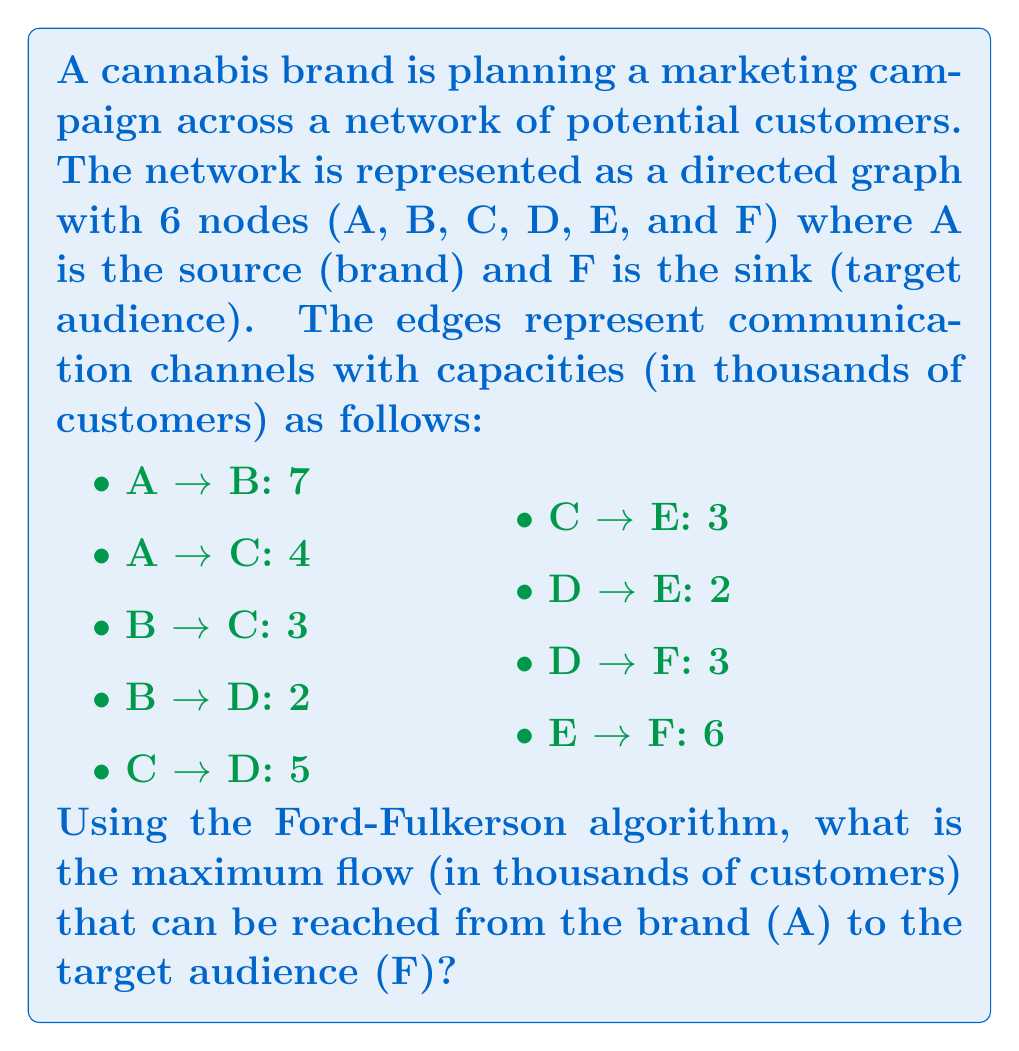Help me with this question. To solve this problem, we'll use the Ford-Fulkerson algorithm to find the maximum flow in the network. Here's a step-by-step explanation:

1. Initialize the flow to 0 for all edges.

2. Find an augmenting path from source A to sink F. We'll use depth-first search (DFS) for this.

3. Augment the flow along the found path by the minimum capacity along that path.

4. Repeat steps 2-3 until no augmenting path can be found.

Let's go through the iterations:

Iteration 1:
Path: A → B → D → F
Min capacity: min(7, 2, 3) = 2
Flow: 2

Iteration 2:
Path: A → C → D → F
Min capacity: min(4, 5, 3) = 3
Flow: 2 + 3 = 5

Iteration 3:
Path: A → B → C → E → F
Min capacity: min(5, 3, 3, 6) = 3
Flow: 5 + 3 = 8

Iteration 4:
Path: A → C → E → F
Min capacity: min(1, 3, 3) = 1
Flow: 8 + 1 = 9

No more augmenting paths can be found.

The final flow network:

A → B: 5/7
A → C: 4/4
B → C: 3/3
B → D: 2/2
C → D: 3/5
C → E: 4/3
D → E: 0/2
D → F: 5/3
E → F: 4/6

The maximum flow is the sum of flows leaving the source A, which is 5 + 4 = 9.
Answer: The maximum flow from the brand (A) to the target audience (F) is 9,000 customers. 